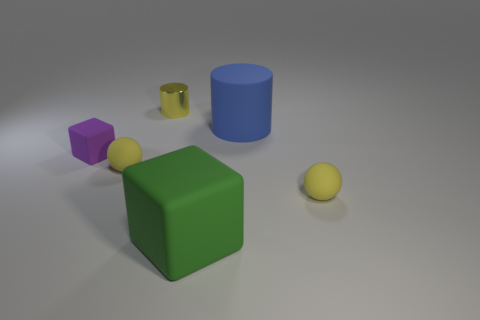How many objects are there, and can you describe their shapes? There are five objects in the image: a large green cube, a smaller purple cube, a blue cylinder, a smaller yellow shiny cylinder, and a small yellow sphere. These shapes suggest an assortment of geometric forms used perhaps for educational or design purposes. 